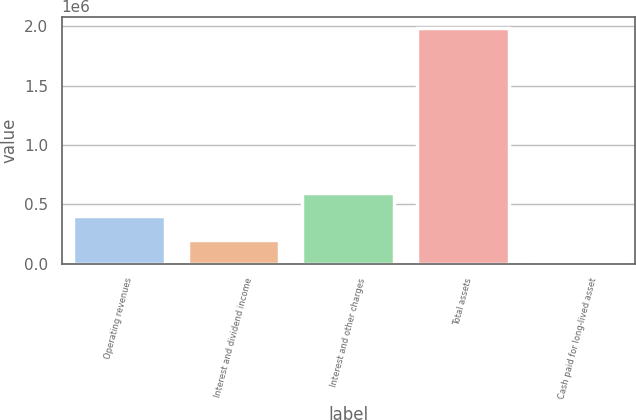Convert chart. <chart><loc_0><loc_0><loc_500><loc_500><bar_chart><fcel>Operating revenues<fcel>Interest and dividend income<fcel>Interest and other charges<fcel>Total assets<fcel>Cash paid for long-lived asset<nl><fcel>398689<fcel>200722<fcel>596656<fcel>1.98243e+06<fcel>2754<nl></chart> 